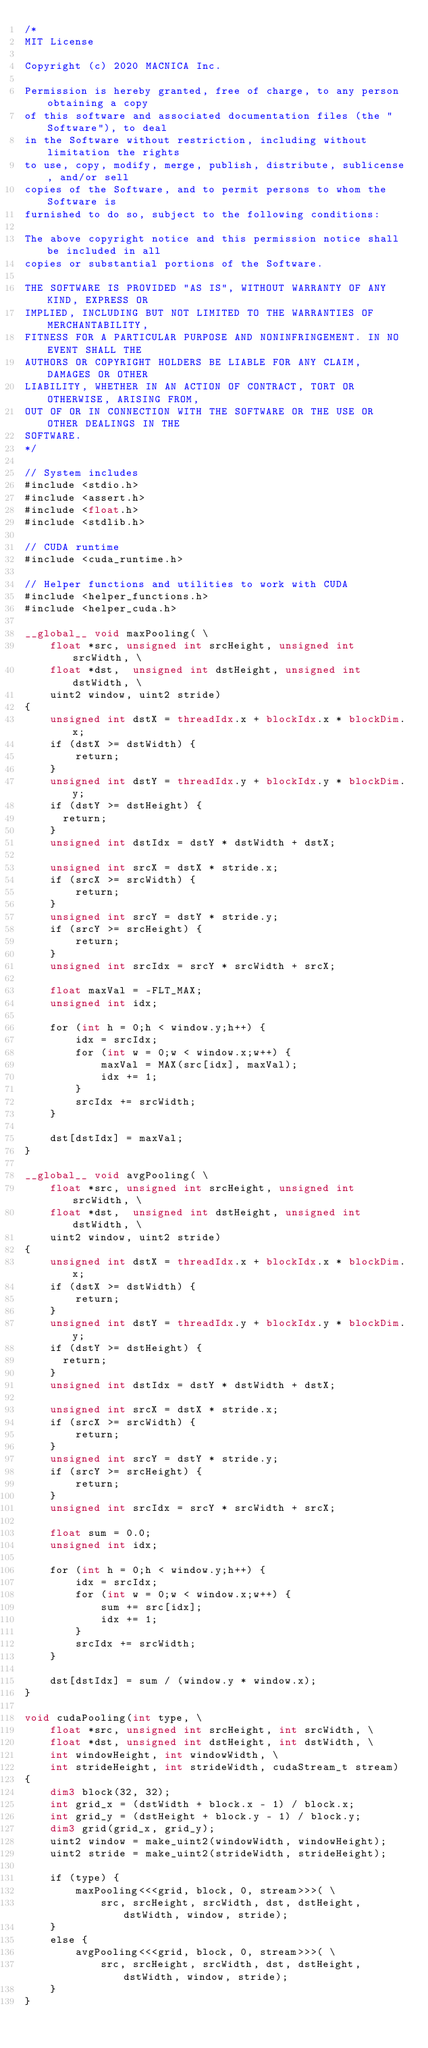Convert code to text. <code><loc_0><loc_0><loc_500><loc_500><_Cuda_>/*
MIT License

Copyright (c) 2020 MACNICA Inc.

Permission is hereby granted, free of charge, to any person obtaining a copy
of this software and associated documentation files (the "Software"), to deal
in the Software without restriction, including without limitation the rights
to use, copy, modify, merge, publish, distribute, sublicense, and/or sell
copies of the Software, and to permit persons to whom the Software is
furnished to do so, subject to the following conditions:

The above copyright notice and this permission notice shall be included in all
copies or substantial portions of the Software.

THE SOFTWARE IS PROVIDED "AS IS", WITHOUT WARRANTY OF ANY KIND, EXPRESS OR
IMPLIED, INCLUDING BUT NOT LIMITED TO THE WARRANTIES OF MERCHANTABILITY,
FITNESS FOR A PARTICULAR PURPOSE AND NONINFRINGEMENT. IN NO EVENT SHALL THE
AUTHORS OR COPYRIGHT HOLDERS BE LIABLE FOR ANY CLAIM, DAMAGES OR OTHER
LIABILITY, WHETHER IN AN ACTION OF CONTRACT, TORT OR OTHERWISE, ARISING FROM,
OUT OF OR IN CONNECTION WITH THE SOFTWARE OR THE USE OR OTHER DEALINGS IN THE
SOFTWARE.
*/

// System includes
#include <stdio.h>
#include <assert.h>
#include <float.h>
#include <stdlib.h>

// CUDA runtime
#include <cuda_runtime.h>

// Helper functions and utilities to work with CUDA
#include <helper_functions.h>
#include <helper_cuda.h>

__global__ void maxPooling( \
    float *src, unsigned int srcHeight, unsigned int srcWidth, \
    float *dst,  unsigned int dstHeight, unsigned int dstWidth, \
    uint2 window, uint2 stride)
{
    unsigned int dstX = threadIdx.x + blockIdx.x * blockDim.x;
    if (dstX >= dstWidth) {
        return;
    }
    unsigned int dstY = threadIdx.y + blockIdx.y * blockDim.y;
    if (dstY >= dstHeight) {
      return;
    }
    unsigned int dstIdx = dstY * dstWidth + dstX;

    unsigned int srcX = dstX * stride.x;
    if (srcX >= srcWidth) {
        return;
    }
    unsigned int srcY = dstY * stride.y;
    if (srcY >= srcHeight) {
        return;
    }
    unsigned int srcIdx = srcY * srcWidth + srcX;

    float maxVal = -FLT_MAX;
    unsigned int idx;

    for (int h = 0;h < window.y;h++) {
        idx = srcIdx;
        for (int w = 0;w < window.x;w++) {
            maxVal = MAX(src[idx], maxVal);
            idx += 1;
        }
        srcIdx += srcWidth;
    }

    dst[dstIdx] = maxVal;
}

__global__ void avgPooling( \
    float *src, unsigned int srcHeight, unsigned int srcWidth, \
    float *dst,  unsigned int dstHeight, unsigned int dstWidth, \
    uint2 window, uint2 stride)
{
    unsigned int dstX = threadIdx.x + blockIdx.x * blockDim.x;
    if (dstX >= dstWidth) {
        return;
    }
    unsigned int dstY = threadIdx.y + blockIdx.y * blockDim.y;
    if (dstY >= dstHeight) {
      return;
    }
    unsigned int dstIdx = dstY * dstWidth + dstX;

    unsigned int srcX = dstX * stride.x;
    if (srcX >= srcWidth) {
        return;
    }
    unsigned int srcY = dstY * stride.y;
    if (srcY >= srcHeight) {
        return;
    }
    unsigned int srcIdx = srcY * srcWidth + srcX;

    float sum = 0.0;
    unsigned int idx;

    for (int h = 0;h < window.y;h++) {
        idx = srcIdx;
        for (int w = 0;w < window.x;w++) {
            sum += src[idx];
            idx += 1;
        }
        srcIdx += srcWidth;
    }

    dst[dstIdx] = sum / (window.y * window.x);
}

void cudaPooling(int type, \
    float *src, unsigned int srcHeight, int srcWidth, \
    float *dst, unsigned int dstHeight, int dstWidth, \
    int windowHeight, int windowWidth, \
    int strideHeight, int strideWidth, cudaStream_t stream)
{
    dim3 block(32, 32);
    int grid_x = (dstWidth + block.x - 1) / block.x;
    int grid_y = (dstHeight + block.y - 1) / block.y;
    dim3 grid(grid_x, grid_y);
    uint2 window = make_uint2(windowWidth, windowHeight);
    uint2 stride = make_uint2(strideWidth, strideHeight);

    if (type) {
        maxPooling<<<grid, block, 0, stream>>>( \
            src, srcHeight, srcWidth, dst, dstHeight, dstWidth, window, stride);
    }
    else {
        avgPooling<<<grid, block, 0, stream>>>( \
            src, srcHeight, srcWidth, dst, dstHeight, dstWidth, window, stride);
    }
}
</code> 